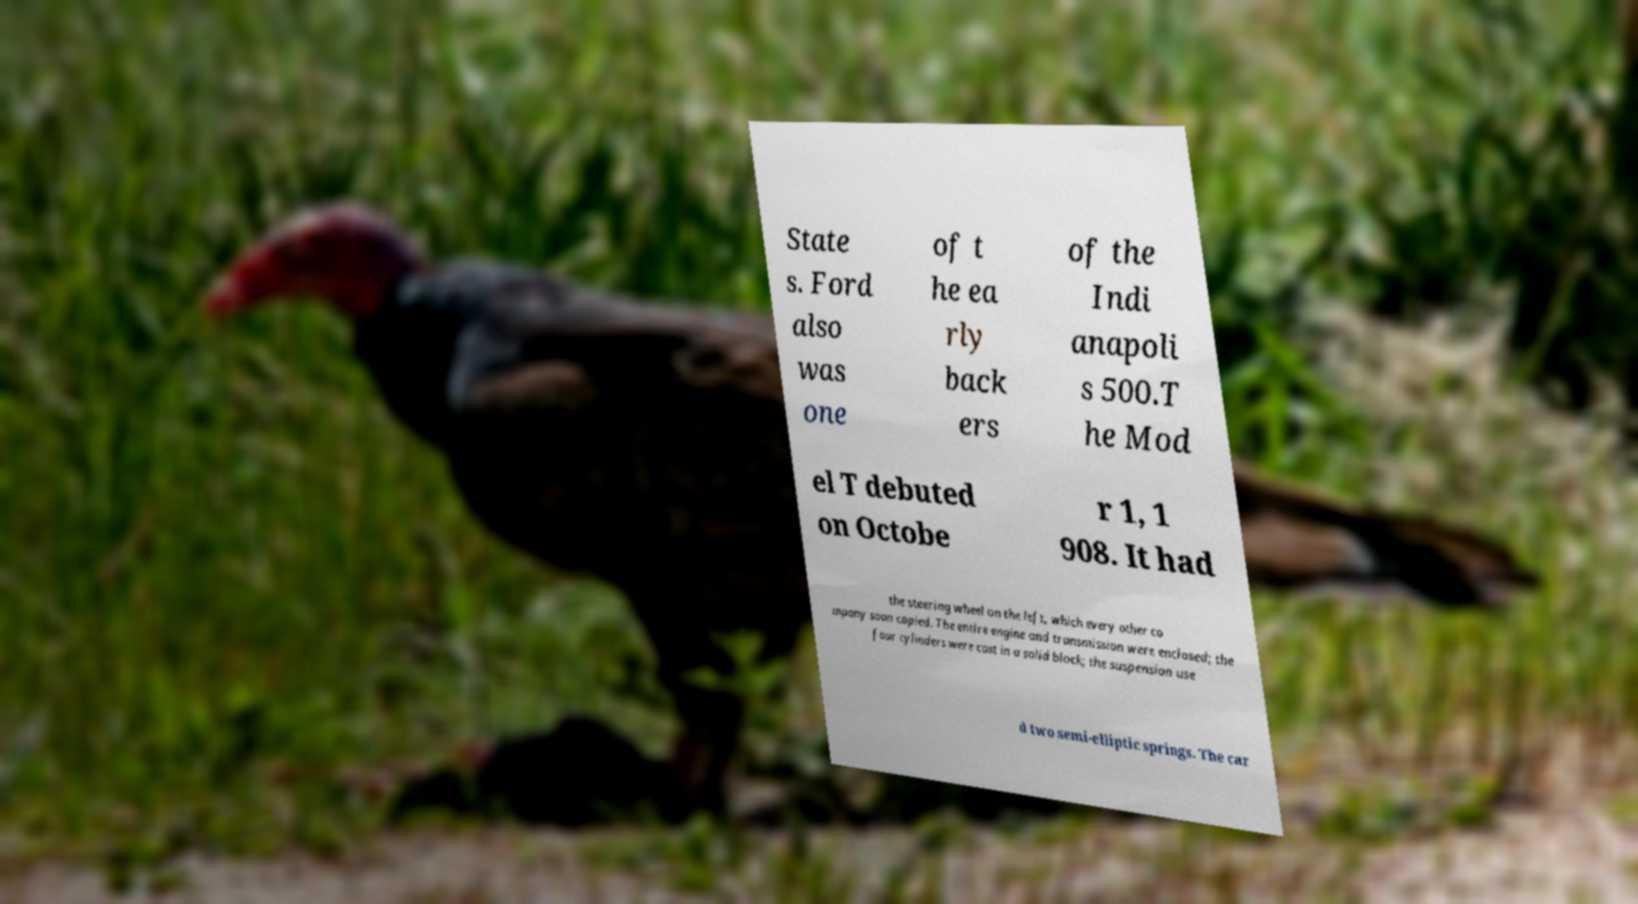Could you extract and type out the text from this image? State s. Ford also was one of t he ea rly back ers of the Indi anapoli s 500.T he Mod el T debuted on Octobe r 1, 1 908. It had the steering wheel on the left, which every other co mpany soon copied. The entire engine and transmission were enclosed; the four cylinders were cast in a solid block; the suspension use d two semi-elliptic springs. The car 